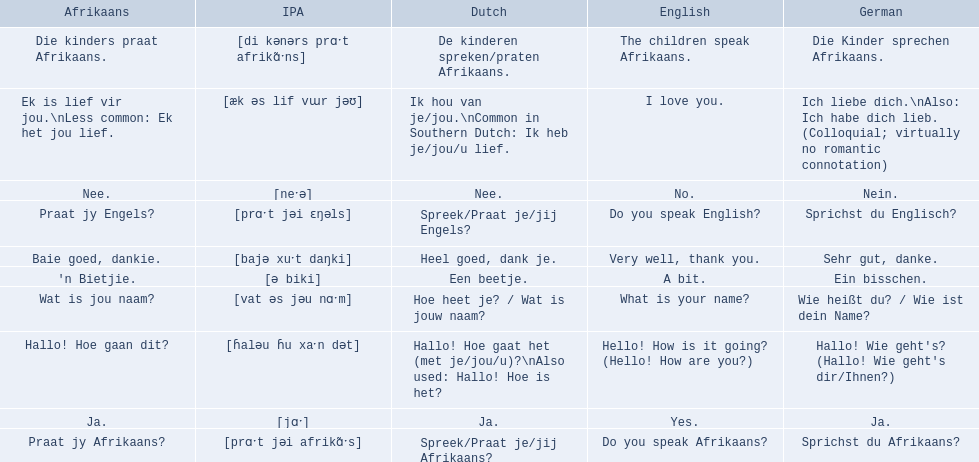What are all of the afrikaans phrases in the list? Hallo! Hoe gaan dit?, Baie goed, dankie., Praat jy Afrikaans?, Praat jy Engels?, Ja., Nee., 'n Bietjie., Wat is jou naam?, Die kinders praat Afrikaans., Ek is lief vir jou.\nLess common: Ek het jou lief. What is the english translation of each phrase? Hello! How is it going? (Hello! How are you?), Very well, thank you., Do you speak Afrikaans?, Do you speak English?, Yes., No., A bit., What is your name?, The children speak Afrikaans., I love you. And which afrikaans phrase translated to do you speak afrikaans? Praat jy Afrikaans?. 